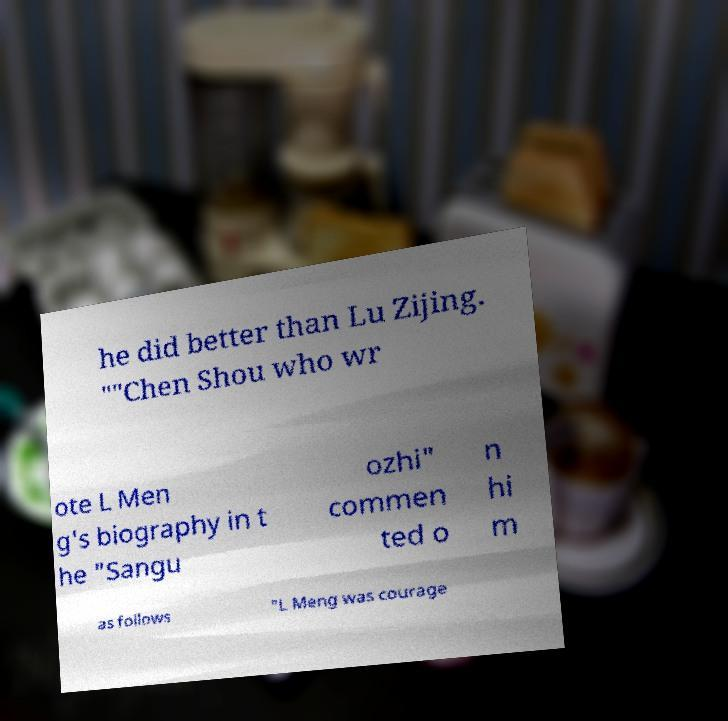For documentation purposes, I need the text within this image transcribed. Could you provide that? he did better than Lu Zijing. ""Chen Shou who wr ote L Men g's biography in t he "Sangu ozhi" commen ted o n hi m as follows "L Meng was courage 